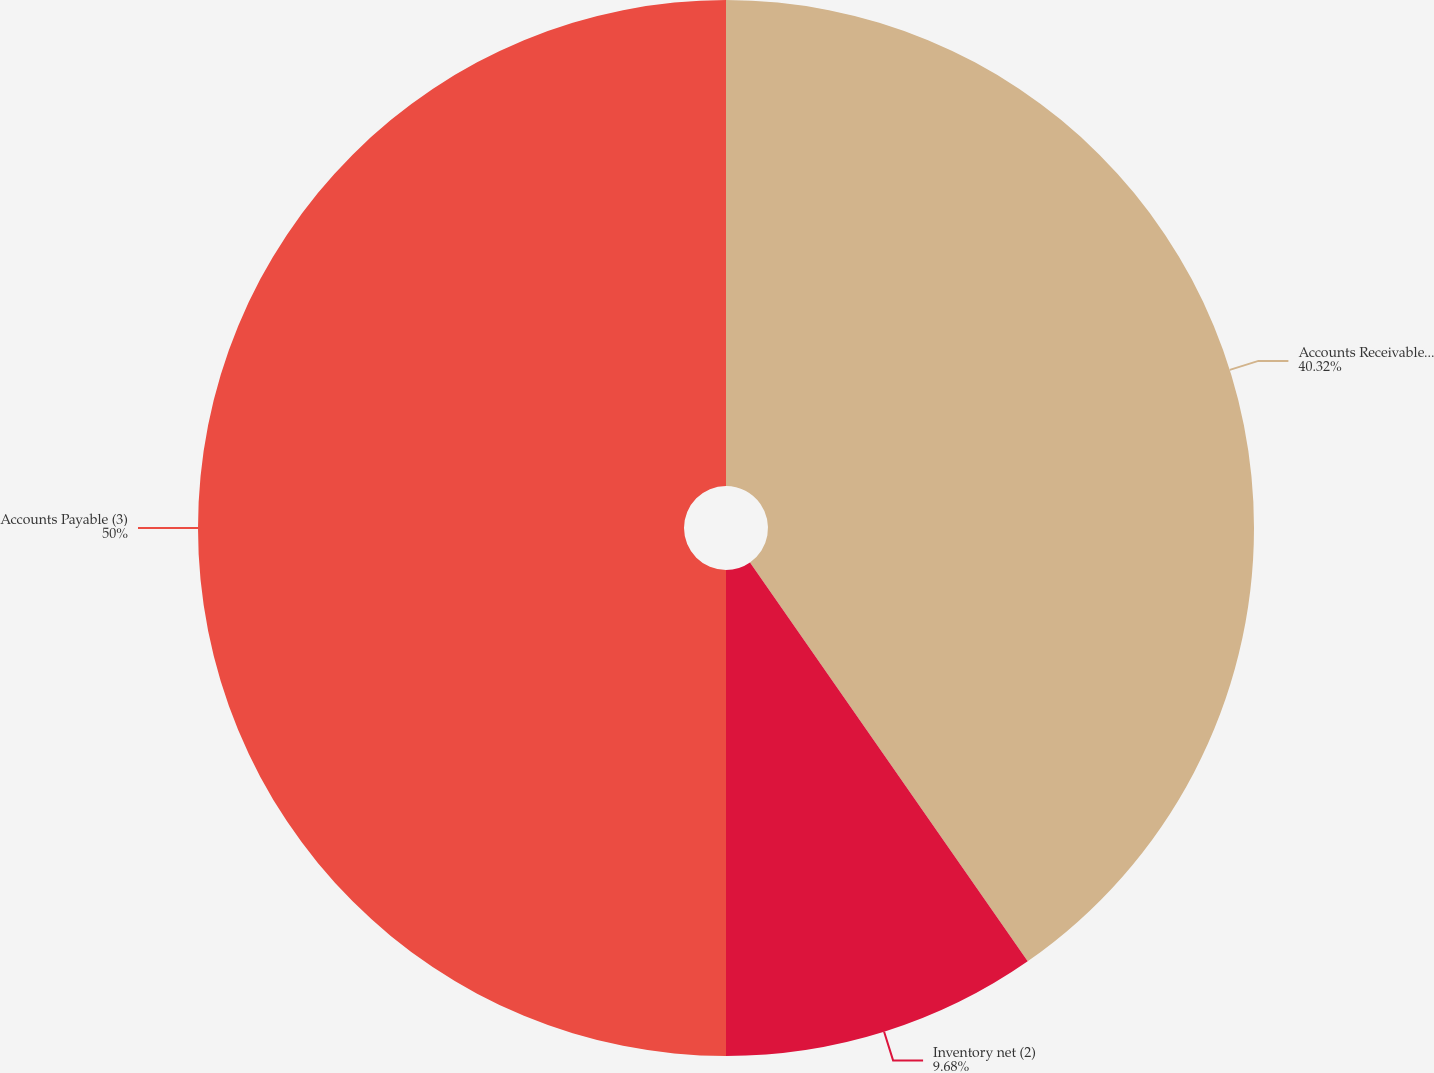Convert chart to OTSL. <chart><loc_0><loc_0><loc_500><loc_500><pie_chart><fcel>Accounts Receivable net (1)<fcel>Inventory net (2)<fcel>Accounts Payable (3)<nl><fcel>40.32%<fcel>9.68%<fcel>50.0%<nl></chart> 